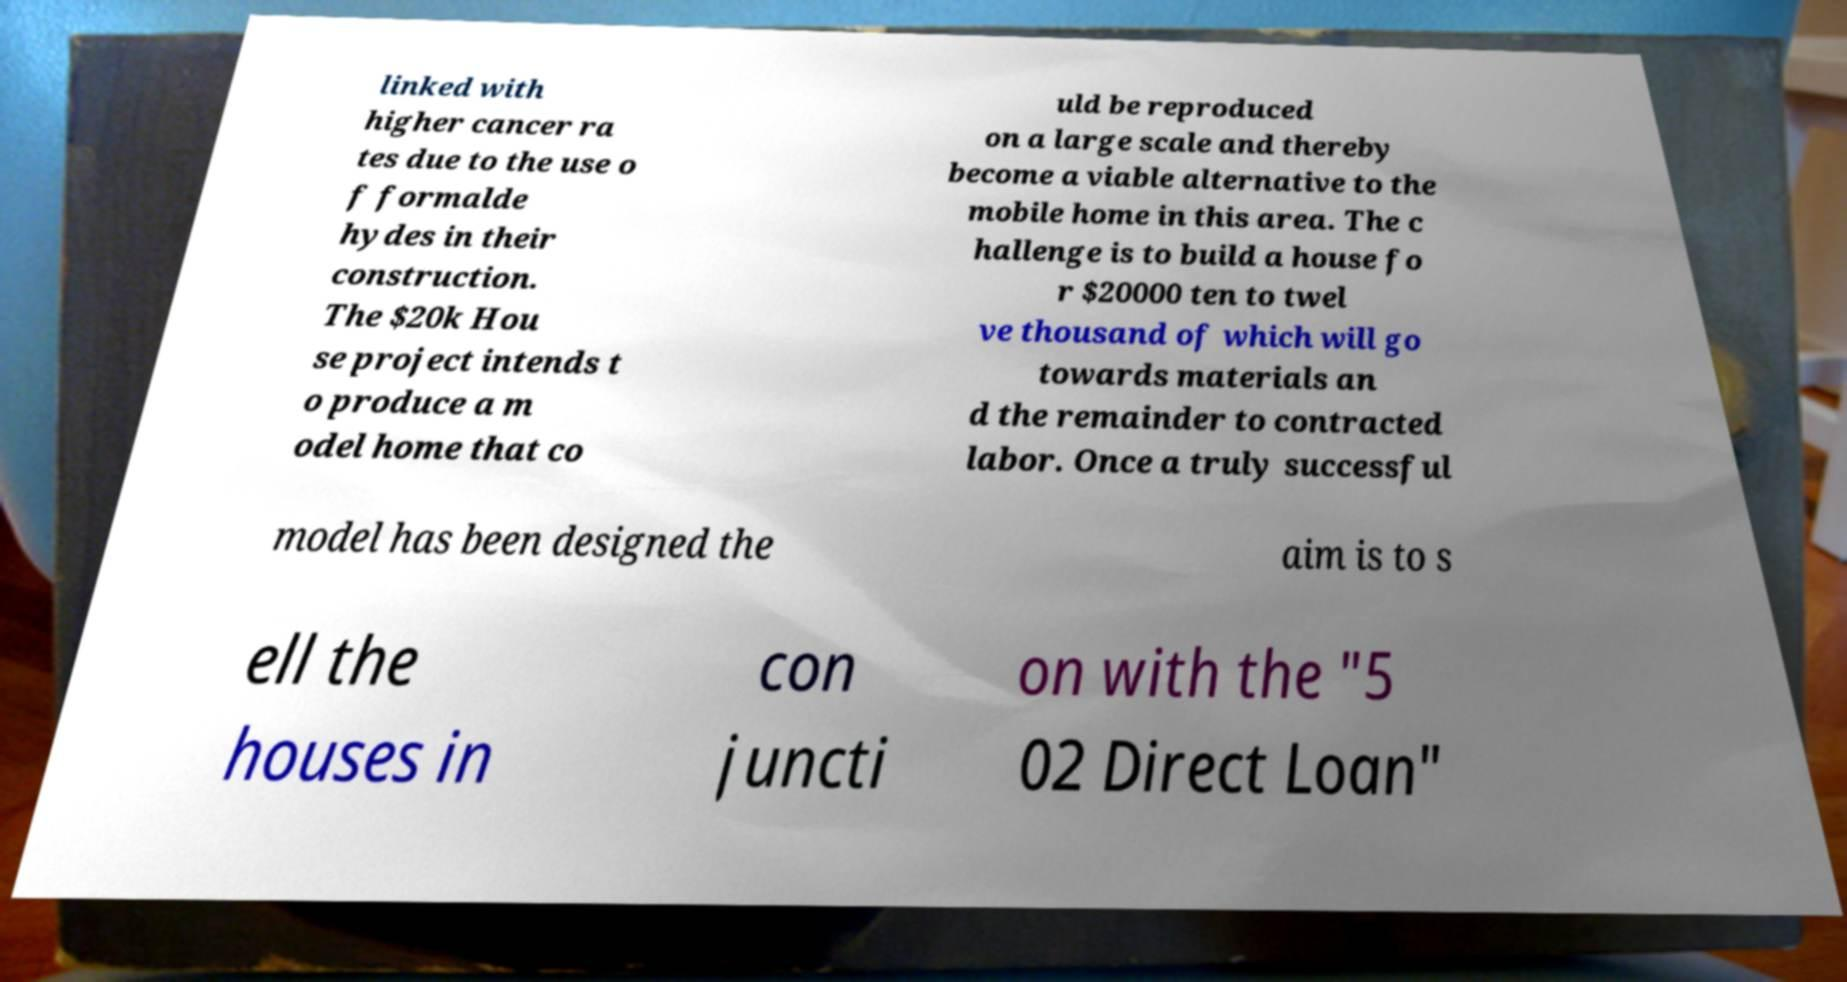Can you accurately transcribe the text from the provided image for me? linked with higher cancer ra tes due to the use o f formalde hydes in their construction. The $20k Hou se project intends t o produce a m odel home that co uld be reproduced on a large scale and thereby become a viable alternative to the mobile home in this area. The c hallenge is to build a house fo r $20000 ten to twel ve thousand of which will go towards materials an d the remainder to contracted labor. Once a truly successful model has been designed the aim is to s ell the houses in con juncti on with the "5 02 Direct Loan" 